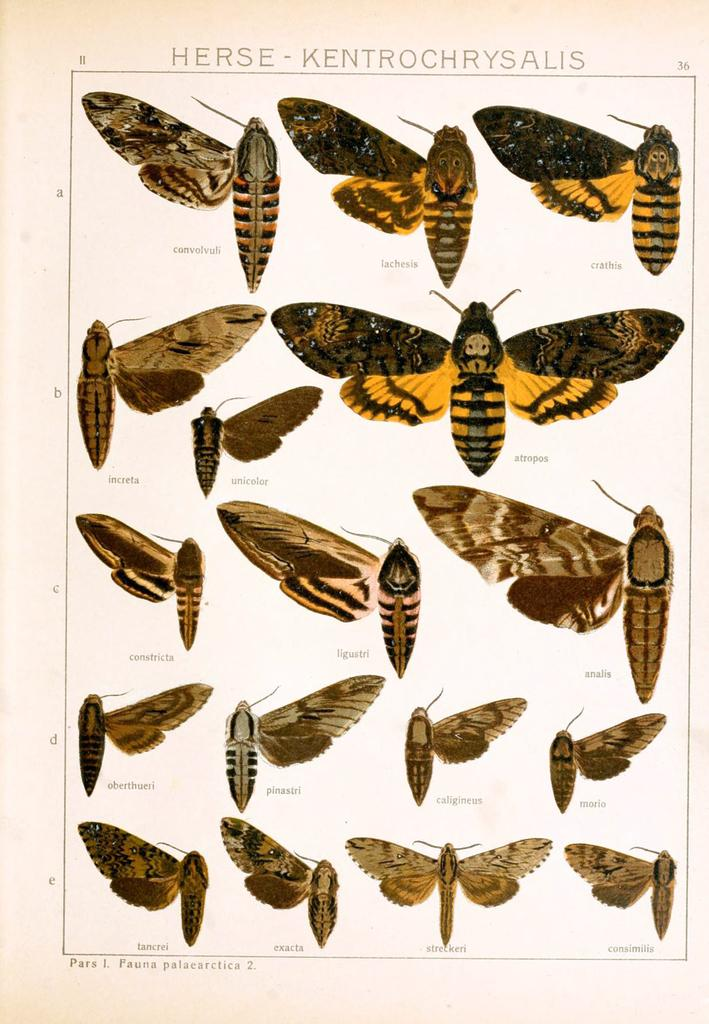What is featured in the image? There is a poster in the image. What type of images are on the poster? The poster contains pictures of insects. Is there any text on the poster? Yes, there is text on the poster. What type of silver is being used by the team in the image? There is no silver or team present in the image; it only features a poster with pictures of insects and text. 